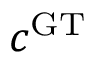<formula> <loc_0><loc_0><loc_500><loc_500>c ^ { G T }</formula> 